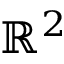Convert formula to latex. <formula><loc_0><loc_0><loc_500><loc_500>\mathbb { R } ^ { 2 }</formula> 